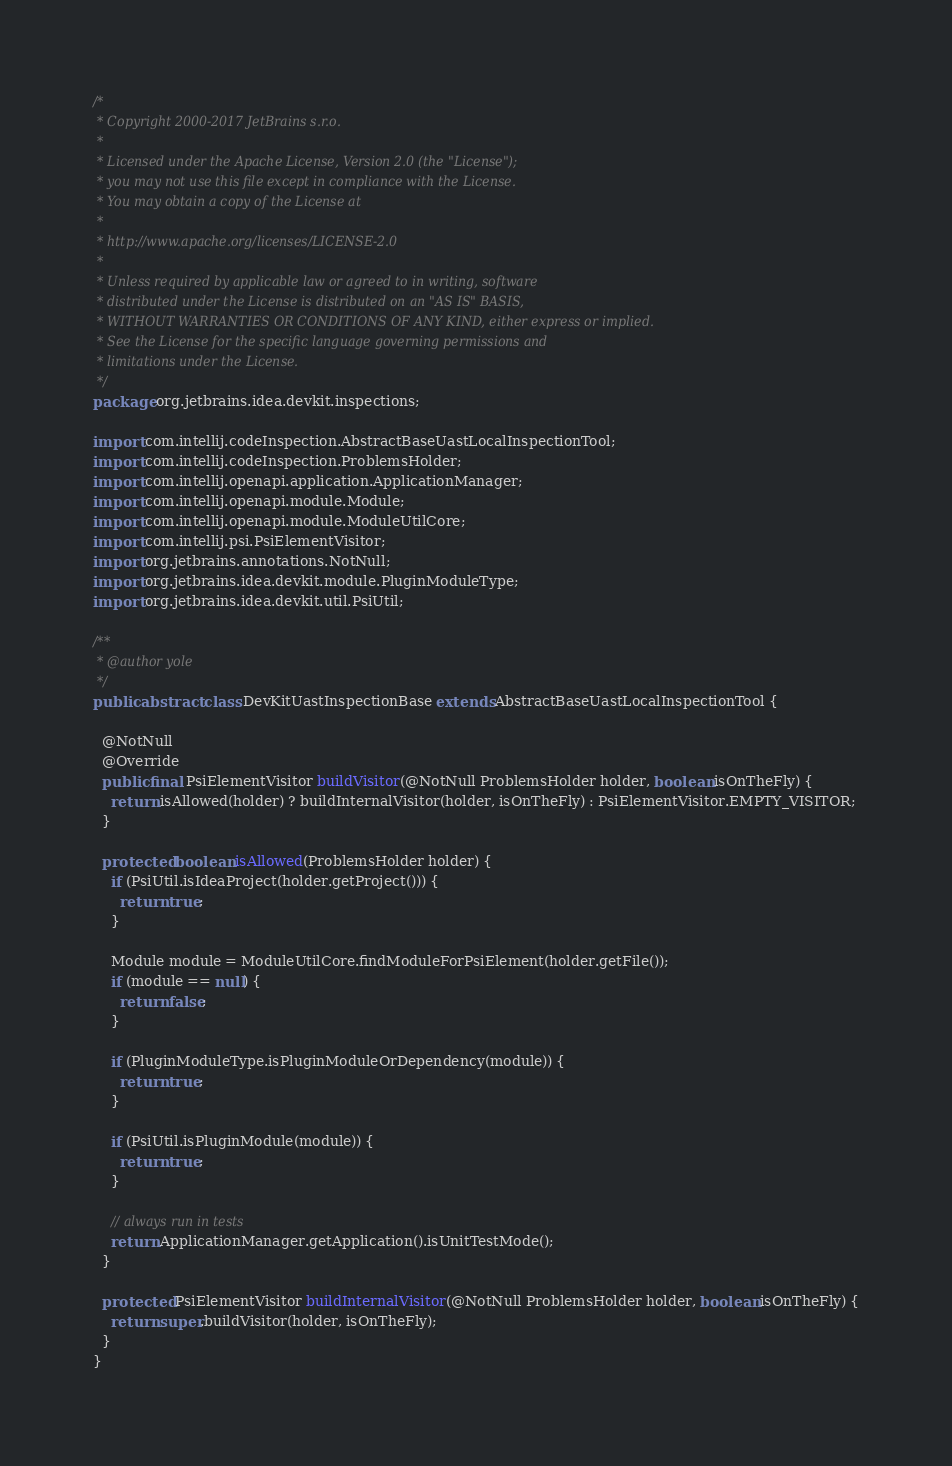Convert code to text. <code><loc_0><loc_0><loc_500><loc_500><_Java_>/*
 * Copyright 2000-2017 JetBrains s.r.o.
 *
 * Licensed under the Apache License, Version 2.0 (the "License");
 * you may not use this file except in compliance with the License.
 * You may obtain a copy of the License at
 *
 * http://www.apache.org/licenses/LICENSE-2.0
 *
 * Unless required by applicable law or agreed to in writing, software
 * distributed under the License is distributed on an "AS IS" BASIS,
 * WITHOUT WARRANTIES OR CONDITIONS OF ANY KIND, either express or implied.
 * See the License for the specific language governing permissions and
 * limitations under the License.
 */
package org.jetbrains.idea.devkit.inspections;

import com.intellij.codeInspection.AbstractBaseUastLocalInspectionTool;
import com.intellij.codeInspection.ProblemsHolder;
import com.intellij.openapi.application.ApplicationManager;
import com.intellij.openapi.module.Module;
import com.intellij.openapi.module.ModuleUtilCore;
import com.intellij.psi.PsiElementVisitor;
import org.jetbrains.annotations.NotNull;
import org.jetbrains.idea.devkit.module.PluginModuleType;
import org.jetbrains.idea.devkit.util.PsiUtil;

/**
 * @author yole
 */
public abstract class DevKitUastInspectionBase extends AbstractBaseUastLocalInspectionTool {

  @NotNull
  @Override
  public final PsiElementVisitor buildVisitor(@NotNull ProblemsHolder holder, boolean isOnTheFly) {
    return isAllowed(holder) ? buildInternalVisitor(holder, isOnTheFly) : PsiElementVisitor.EMPTY_VISITOR;
  }

  protected boolean isAllowed(ProblemsHolder holder) {
    if (PsiUtil.isIdeaProject(holder.getProject())) {
      return true;
    }

    Module module = ModuleUtilCore.findModuleForPsiElement(holder.getFile());
    if (module == null) {
      return false;
    }

    if (PluginModuleType.isPluginModuleOrDependency(module)) {
      return true;
    }

    if (PsiUtil.isPluginModule(module)) {
      return true;
    }

    // always run in tests
    return ApplicationManager.getApplication().isUnitTestMode();
  }

  protected PsiElementVisitor buildInternalVisitor(@NotNull ProblemsHolder holder, boolean isOnTheFly) {
    return super.buildVisitor(holder, isOnTheFly);
  }
}
</code> 